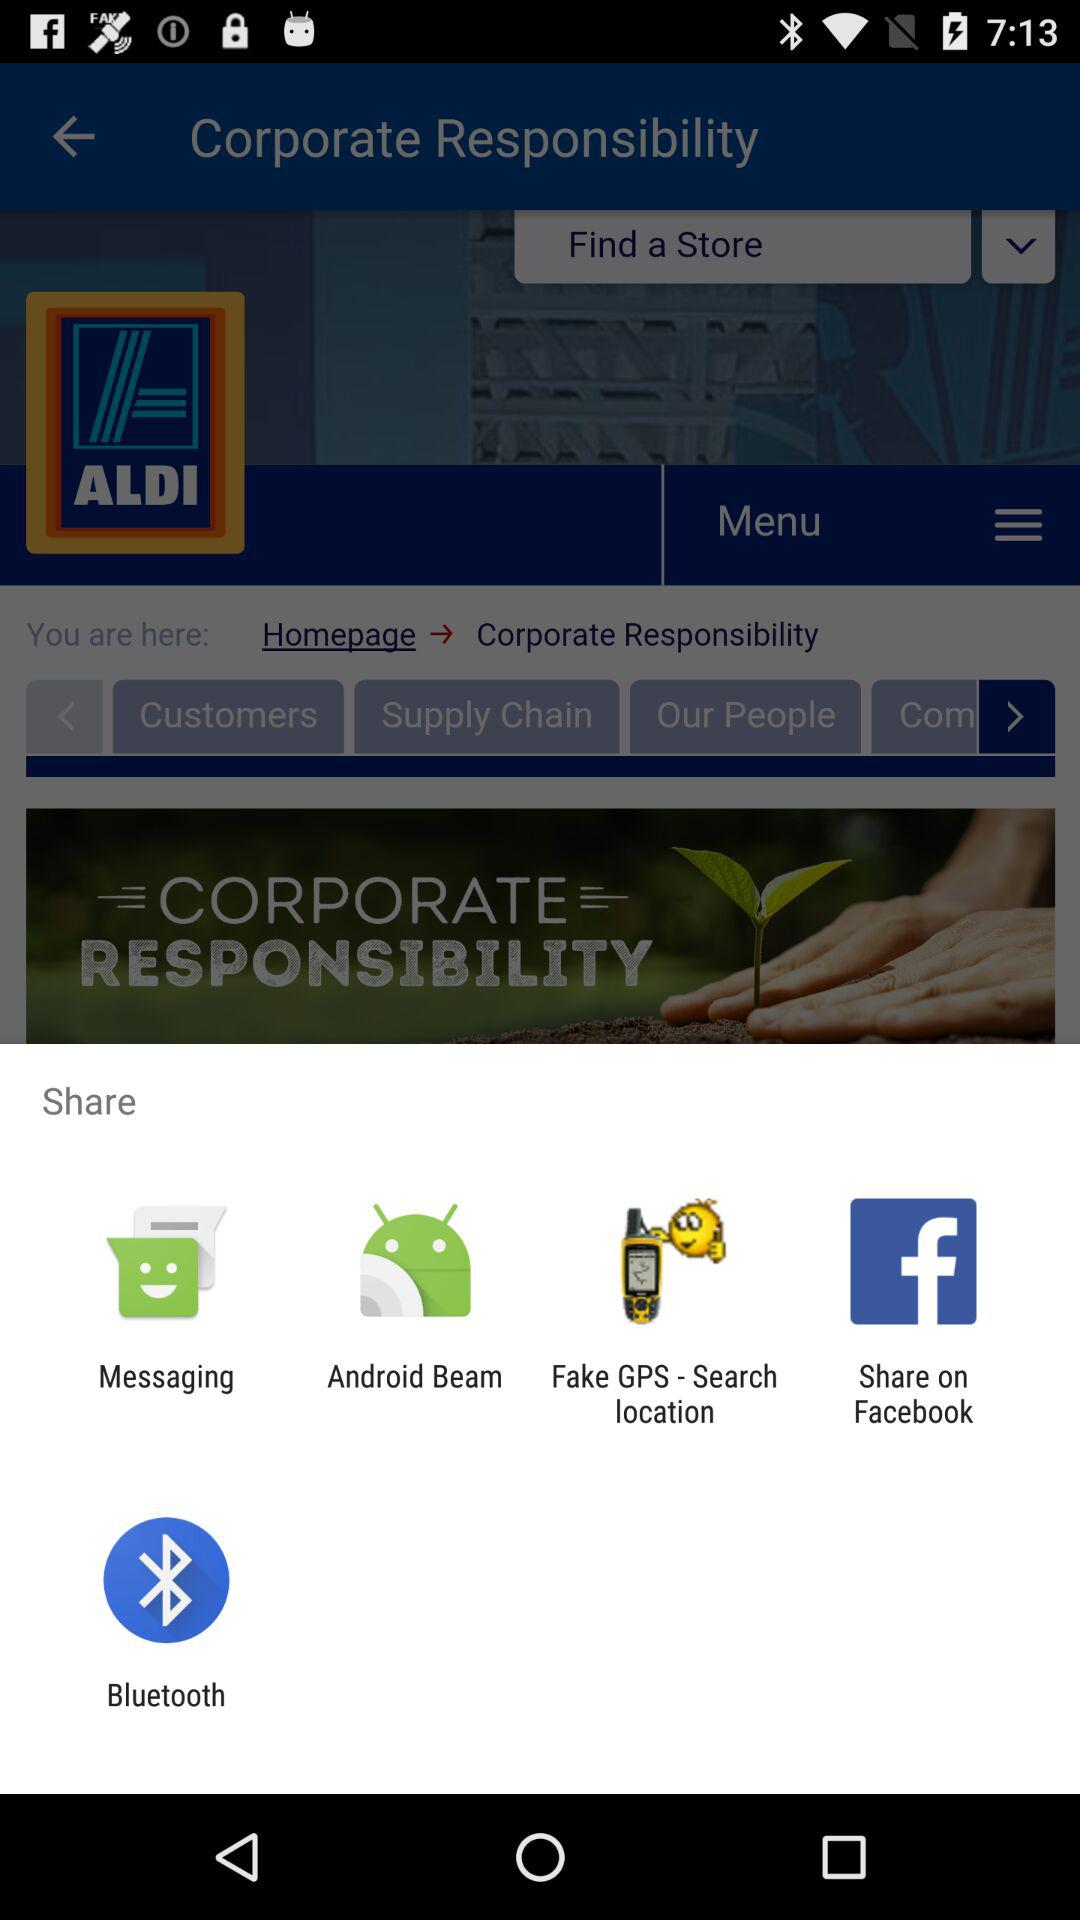Which different apps can be used to share? The different apps that can be used to share are "Messaging", "Android Beam", "Fake GPS - Search location", "Facebook" and "Bluetooth". 